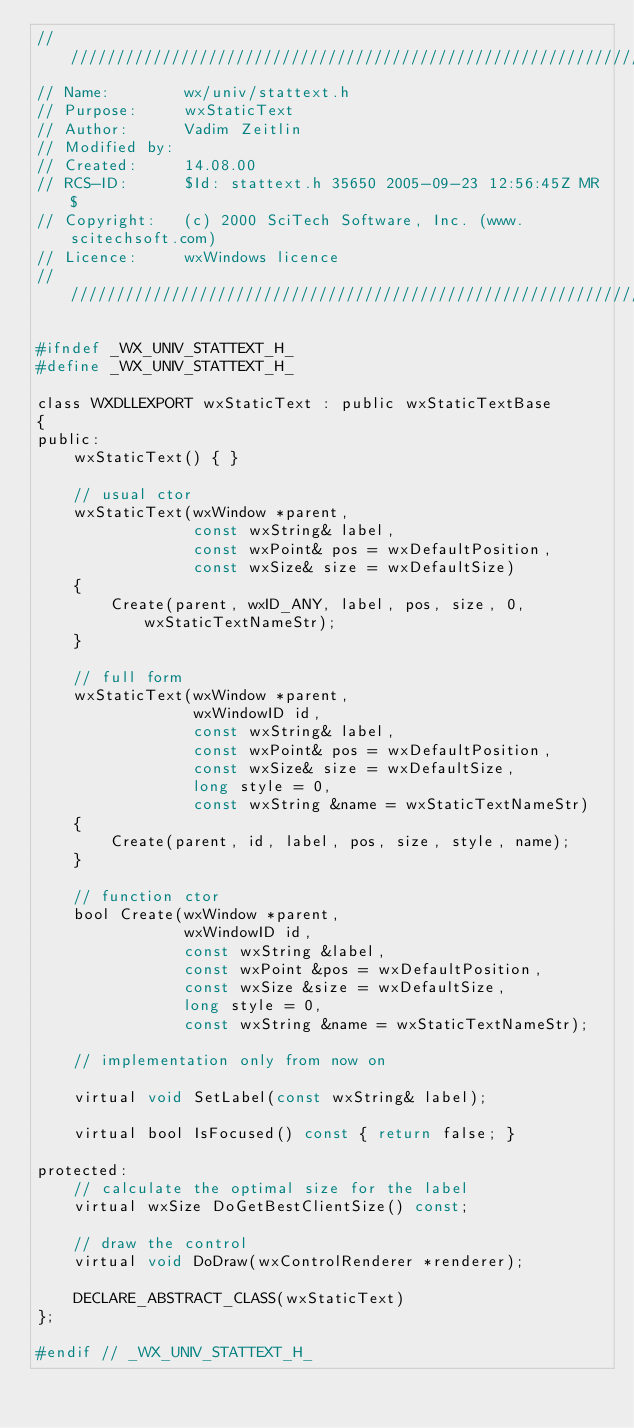<code> <loc_0><loc_0><loc_500><loc_500><_C_>/////////////////////////////////////////////////////////////////////////////
// Name:        wx/univ/stattext.h
// Purpose:     wxStaticText
// Author:      Vadim Zeitlin
// Modified by:
// Created:     14.08.00
// RCS-ID:      $Id: stattext.h 35650 2005-09-23 12:56:45Z MR $
// Copyright:   (c) 2000 SciTech Software, Inc. (www.scitechsoft.com)
// Licence:     wxWindows licence
/////////////////////////////////////////////////////////////////////////////

#ifndef _WX_UNIV_STATTEXT_H_
#define _WX_UNIV_STATTEXT_H_

class WXDLLEXPORT wxStaticText : public wxStaticTextBase
{
public:
    wxStaticText() { }

    // usual ctor
    wxStaticText(wxWindow *parent,
                 const wxString& label,
                 const wxPoint& pos = wxDefaultPosition,
                 const wxSize& size = wxDefaultSize)
    {
        Create(parent, wxID_ANY, label, pos, size, 0, wxStaticTextNameStr);
    }

    // full form
    wxStaticText(wxWindow *parent,
                 wxWindowID id,
                 const wxString& label,
                 const wxPoint& pos = wxDefaultPosition,
                 const wxSize& size = wxDefaultSize,
                 long style = 0,
                 const wxString &name = wxStaticTextNameStr)
    {
        Create(parent, id, label, pos, size, style, name);
    }

    // function ctor
    bool Create(wxWindow *parent,
                wxWindowID id,
                const wxString &label,
                const wxPoint &pos = wxDefaultPosition,
                const wxSize &size = wxDefaultSize,
                long style = 0,
                const wxString &name = wxStaticTextNameStr);

    // implementation only from now on

    virtual void SetLabel(const wxString& label);

    virtual bool IsFocused() const { return false; }

protected:
    // calculate the optimal size for the label
    virtual wxSize DoGetBestClientSize() const;

    // draw the control
    virtual void DoDraw(wxControlRenderer *renderer);

    DECLARE_ABSTRACT_CLASS(wxStaticText)
};

#endif // _WX_UNIV_STATTEXT_H_
</code> 